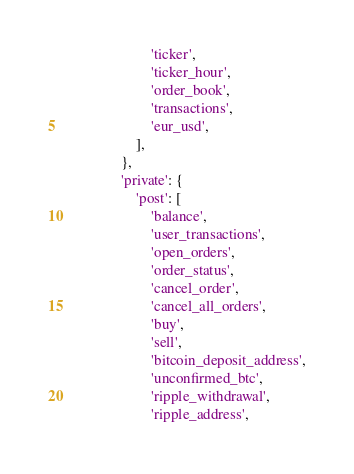Convert code to text. <code><loc_0><loc_0><loc_500><loc_500><_Python_>                        'ticker',
                        'ticker_hour',
                        'order_book',
                        'transactions',
                        'eur_usd',
                    ],
                },
                'private': {
                    'post': [
                        'balance',
                        'user_transactions',
                        'open_orders',
                        'order_status',
                        'cancel_order',
                        'cancel_all_orders',
                        'buy',
                        'sell',
                        'bitcoin_deposit_address',
                        'unconfirmed_btc',
                        'ripple_withdrawal',
                        'ripple_address',</code> 